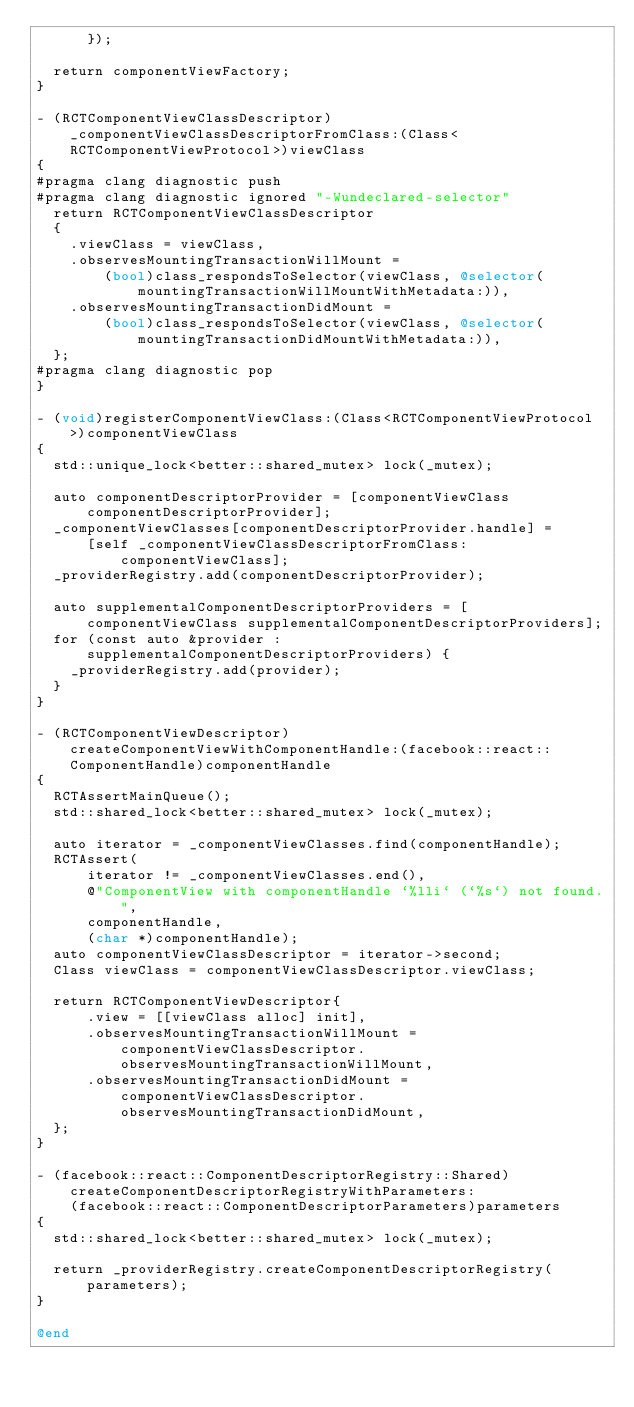Convert code to text. <code><loc_0><loc_0><loc_500><loc_500><_ObjectiveC_>      });

  return componentViewFactory;
}

- (RCTComponentViewClassDescriptor)_componentViewClassDescriptorFromClass:(Class<RCTComponentViewProtocol>)viewClass
{
#pragma clang diagnostic push
#pragma clang diagnostic ignored "-Wundeclared-selector"
  return RCTComponentViewClassDescriptor
  {
    .viewClass = viewClass,
    .observesMountingTransactionWillMount =
        (bool)class_respondsToSelector(viewClass, @selector(mountingTransactionWillMountWithMetadata:)),
    .observesMountingTransactionDidMount =
        (bool)class_respondsToSelector(viewClass, @selector(mountingTransactionDidMountWithMetadata:)),
  };
#pragma clang diagnostic pop
}

- (void)registerComponentViewClass:(Class<RCTComponentViewProtocol>)componentViewClass
{
  std::unique_lock<better::shared_mutex> lock(_mutex);

  auto componentDescriptorProvider = [componentViewClass componentDescriptorProvider];
  _componentViewClasses[componentDescriptorProvider.handle] =
      [self _componentViewClassDescriptorFromClass:componentViewClass];
  _providerRegistry.add(componentDescriptorProvider);

  auto supplementalComponentDescriptorProviders = [componentViewClass supplementalComponentDescriptorProviders];
  for (const auto &provider : supplementalComponentDescriptorProviders) {
    _providerRegistry.add(provider);
  }
}

- (RCTComponentViewDescriptor)createComponentViewWithComponentHandle:(facebook::react::ComponentHandle)componentHandle
{
  RCTAssertMainQueue();
  std::shared_lock<better::shared_mutex> lock(_mutex);

  auto iterator = _componentViewClasses.find(componentHandle);
  RCTAssert(
      iterator != _componentViewClasses.end(),
      @"ComponentView with componentHandle `%lli` (`%s`) not found.",
      componentHandle,
      (char *)componentHandle);
  auto componentViewClassDescriptor = iterator->second;
  Class viewClass = componentViewClassDescriptor.viewClass;

  return RCTComponentViewDescriptor{
      .view = [[viewClass alloc] init],
      .observesMountingTransactionWillMount = componentViewClassDescriptor.observesMountingTransactionWillMount,
      .observesMountingTransactionDidMount = componentViewClassDescriptor.observesMountingTransactionDidMount,
  };
}

- (facebook::react::ComponentDescriptorRegistry::Shared)createComponentDescriptorRegistryWithParameters:
    (facebook::react::ComponentDescriptorParameters)parameters
{
  std::shared_lock<better::shared_mutex> lock(_mutex);

  return _providerRegistry.createComponentDescriptorRegistry(parameters);
}

@end
</code> 